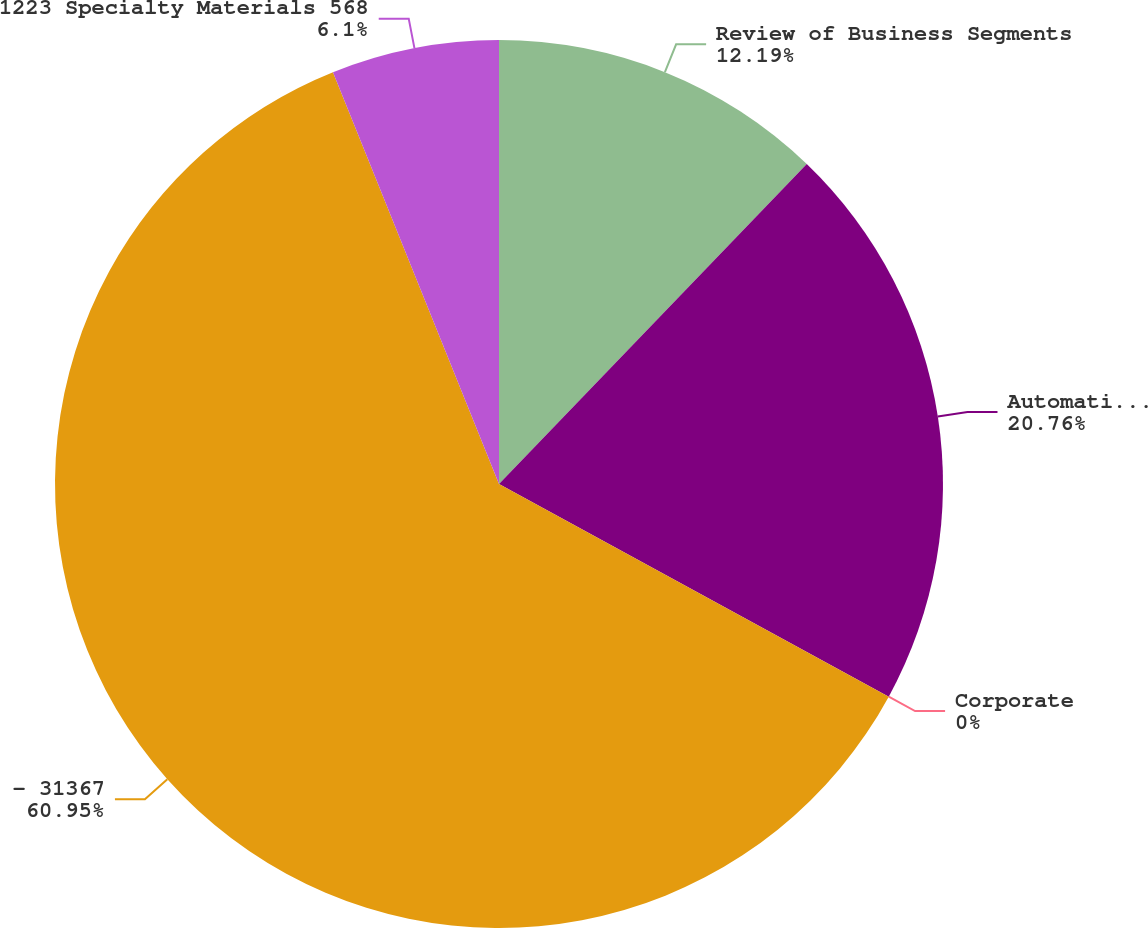<chart> <loc_0><loc_0><loc_500><loc_500><pie_chart><fcel>Review of Business Segments<fcel>Automation and Control<fcel>Corporate<fcel>- 31367<fcel>1223 Specialty Materials 568<nl><fcel>12.19%<fcel>20.76%<fcel>0.0%<fcel>60.95%<fcel>6.1%<nl></chart> 